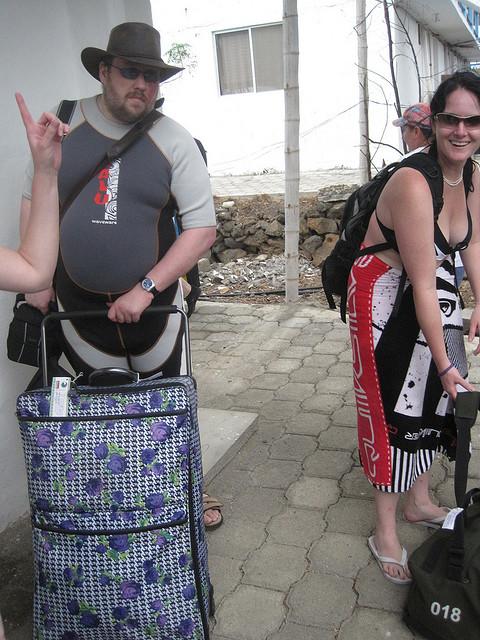What color are the flowers on the left suitcase?
Concise answer only. Purple. Is the man's shirt tight?
Give a very brief answer. Yes. Is the woman's cleavage showing?
Be succinct. Yes. 